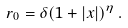<formula> <loc_0><loc_0><loc_500><loc_500>r _ { 0 } = \delta ( 1 + | x | ) ^ { \eta } \, .</formula> 